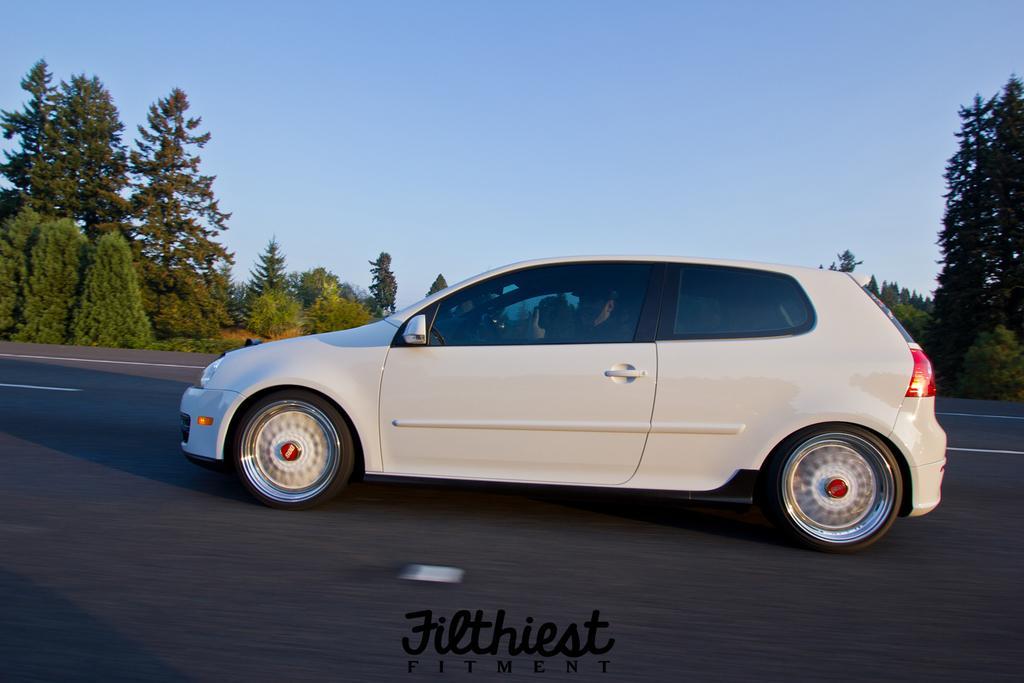In one or two sentences, can you explain what this image depicts? Sky is in blue color. Vehicle is on the road. Background there are trees and plants. Bottom of the image there is a watermark. 